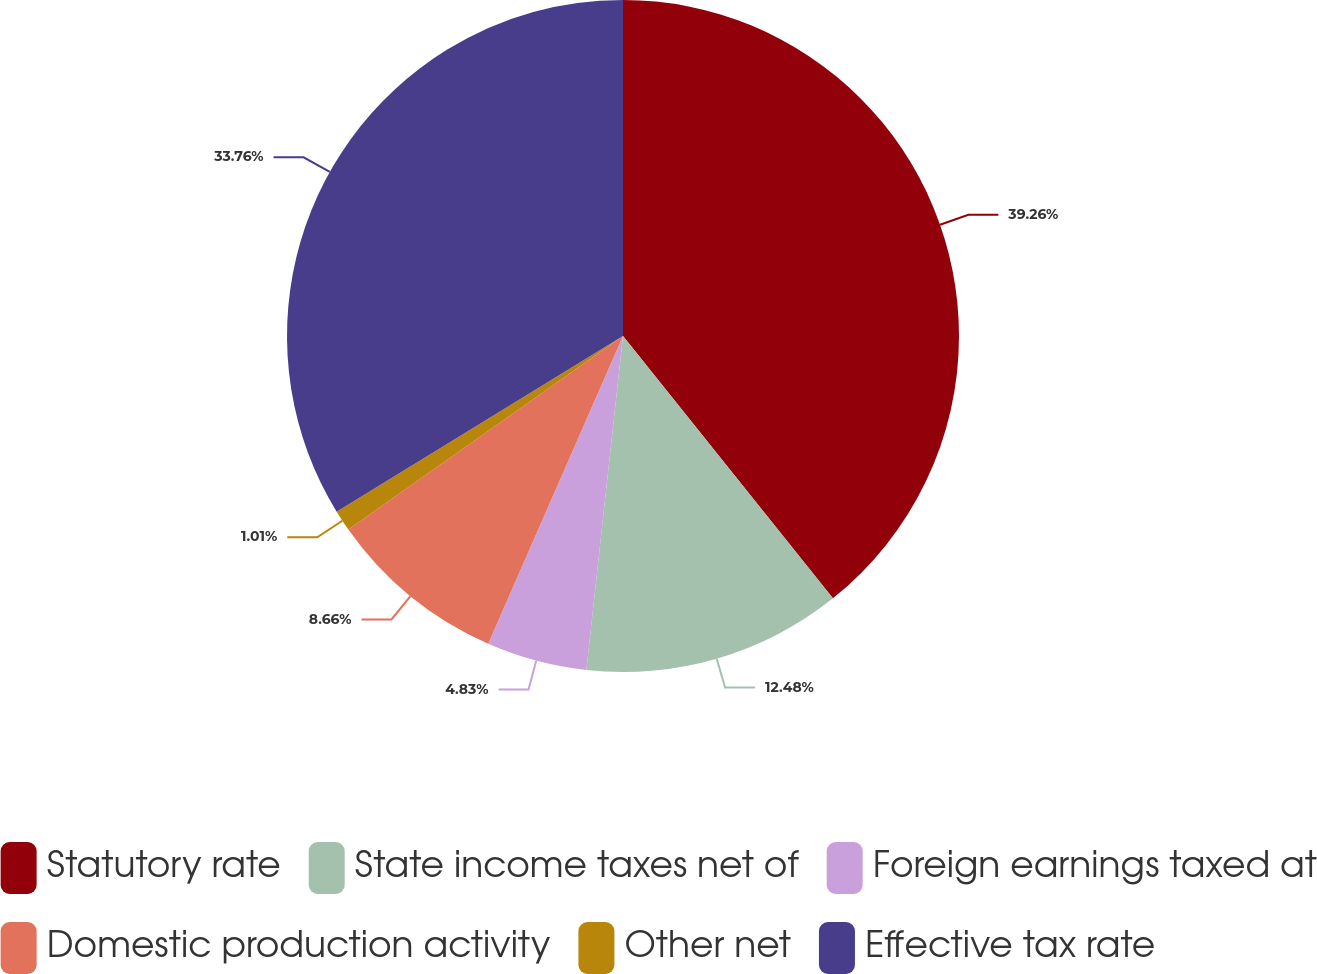Convert chart. <chart><loc_0><loc_0><loc_500><loc_500><pie_chart><fcel>Statutory rate<fcel>State income taxes net of<fcel>Foreign earnings taxed at<fcel>Domestic production activity<fcel>Other net<fcel>Effective tax rate<nl><fcel>39.26%<fcel>12.48%<fcel>4.83%<fcel>8.66%<fcel>1.01%<fcel>33.76%<nl></chart> 